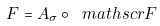Convert formula to latex. <formula><loc_0><loc_0><loc_500><loc_500>F = A _ { \sigma } \circ \ m a t h s c r { F }</formula> 